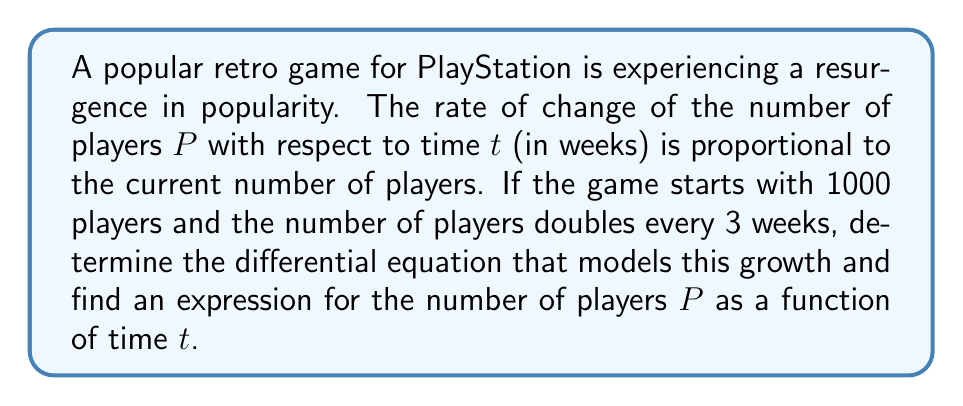Solve this math problem. Let's approach this step-by-step:

1) First, we need to set up the differential equation. The rate of change of players with respect to time is proportional to the current number of players. This can be expressed as:

   $$\frac{dP}{dt} = kP$$

   where $k$ is the proportionality constant.

2) We're told that the number of players doubles every 3 weeks. We can use this to find $k$:

   $$P(3) = 2P(0)$$
   $$P(0)e^{3k} = 2P(0)$$
   $$e^{3k} = 2$$
   $$3k = \ln(2)$$
   $$k = \frac{\ln(2)}{3}$$

3) Now we have our complete differential equation:

   $$\frac{dP}{dt} = \frac{\ln(2)}{3}P$$

4) To solve this, we can separate variables and integrate:

   $$\int \frac{dP}{P} = \int \frac{\ln(2)}{3} dt$$
   $$\ln(P) = \frac{\ln(2)}{3}t + C$$

5) We can find $C$ using the initial condition $P(0) = 1000$:

   $$\ln(1000) = \frac{\ln(2)}{3}(0) + C$$
   $$C = \ln(1000)$$

6) Substituting this back and solving for $P$:

   $$\ln(P) = \frac{\ln(2)}{3}t + \ln(1000)$$
   $$P = e^{\frac{\ln(2)}{3}t + \ln(1000)}$$
   $$P = 1000e^{\frac{\ln(2)}{3}t}$$

This is our final expression for $P$ as a function of $t$.
Answer: The differential equation is $\frac{dP}{dt} = \frac{\ln(2)}{3}P$, and the expression for the number of players $P$ as a function of time $t$ is $P(t) = 1000e^{\frac{\ln(2)}{3}t}$. 